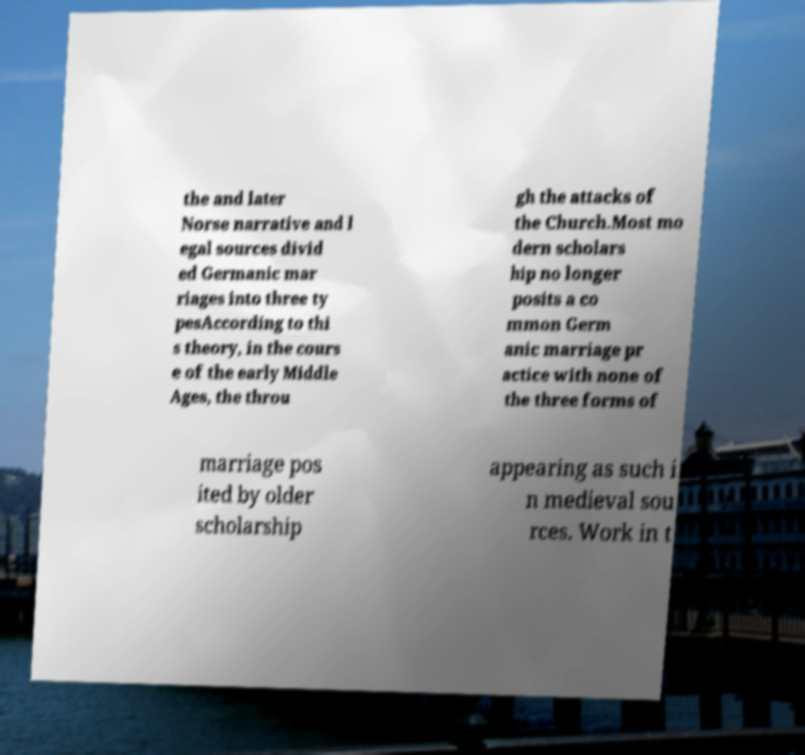Could you assist in decoding the text presented in this image and type it out clearly? the and later Norse narrative and l egal sources divid ed Germanic mar riages into three ty pesAccording to thi s theory, in the cours e of the early Middle Ages, the throu gh the attacks of the Church.Most mo dern scholars hip no longer posits a co mmon Germ anic marriage pr actice with none of the three forms of marriage pos ited by older scholarship appearing as such i n medieval sou rces. Work in t 